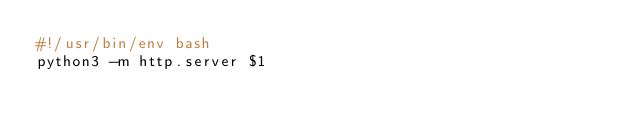<code> <loc_0><loc_0><loc_500><loc_500><_Bash_>#!/usr/bin/env bash
python3 -m http.server $1
</code> 